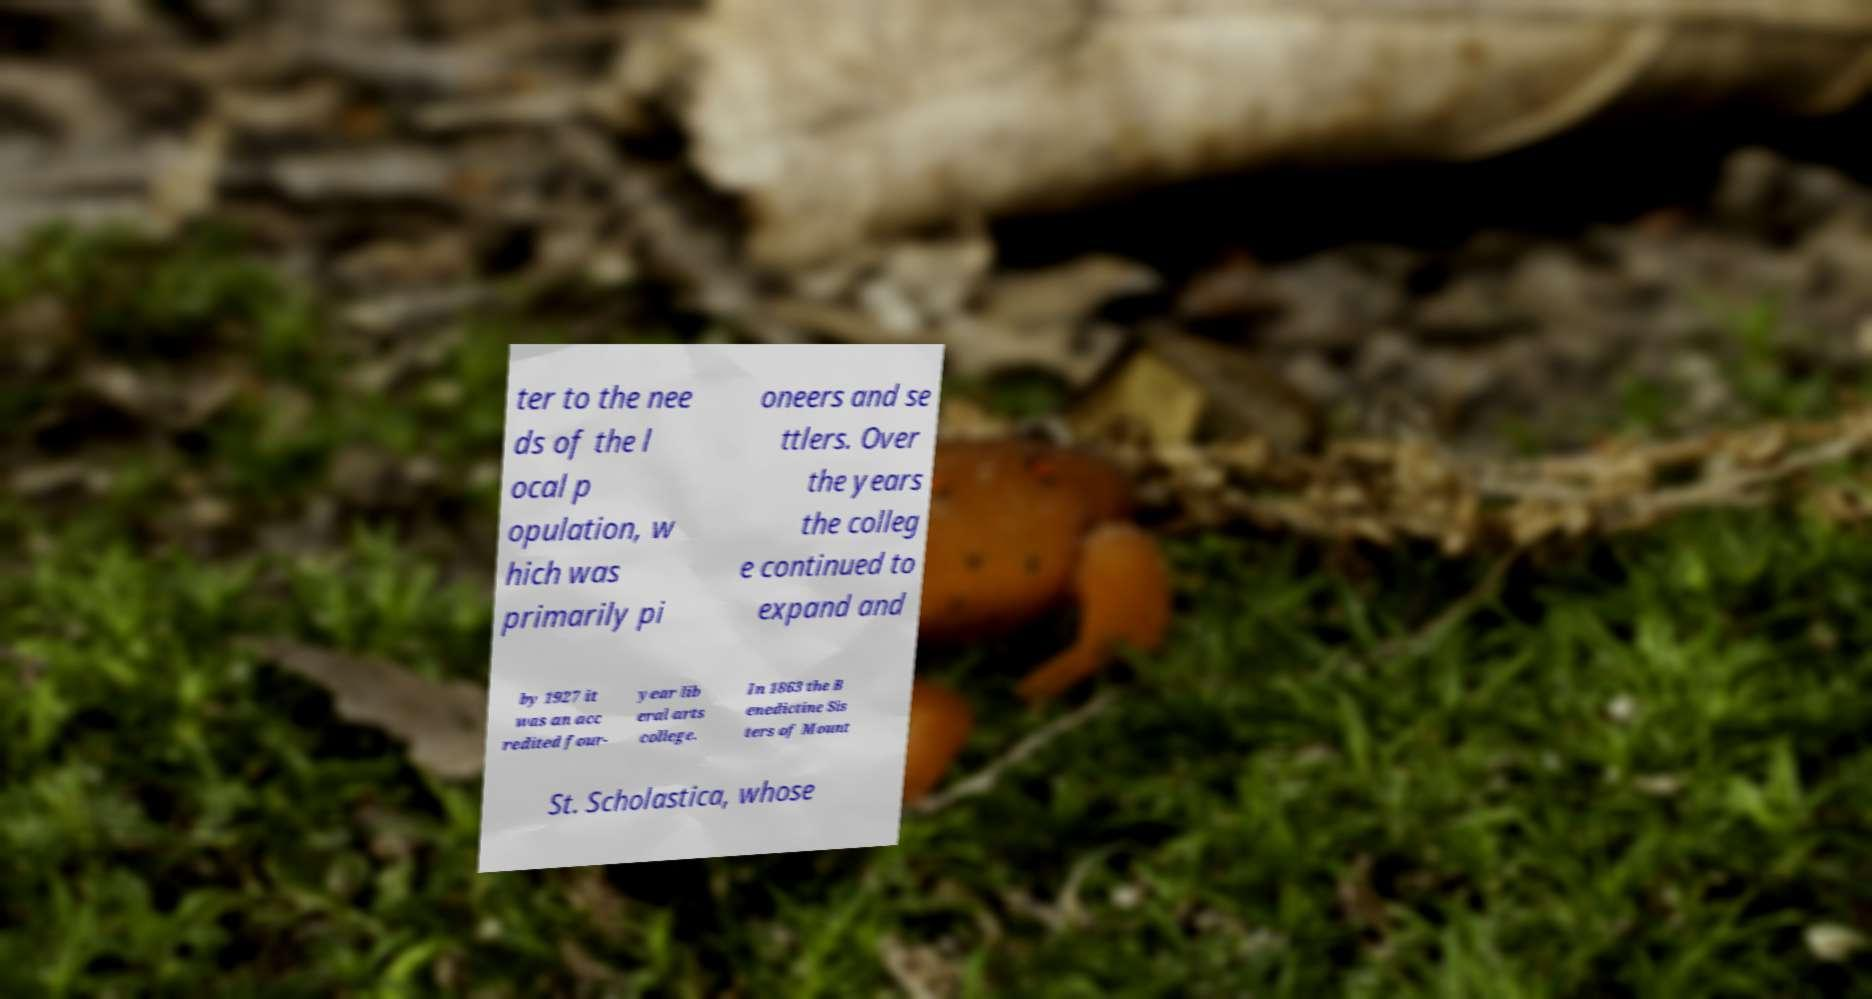I need the written content from this picture converted into text. Can you do that? ter to the nee ds of the l ocal p opulation, w hich was primarily pi oneers and se ttlers. Over the years the colleg e continued to expand and by 1927 it was an acc redited four- year lib eral arts college. In 1863 the B enedictine Sis ters of Mount St. Scholastica, whose 